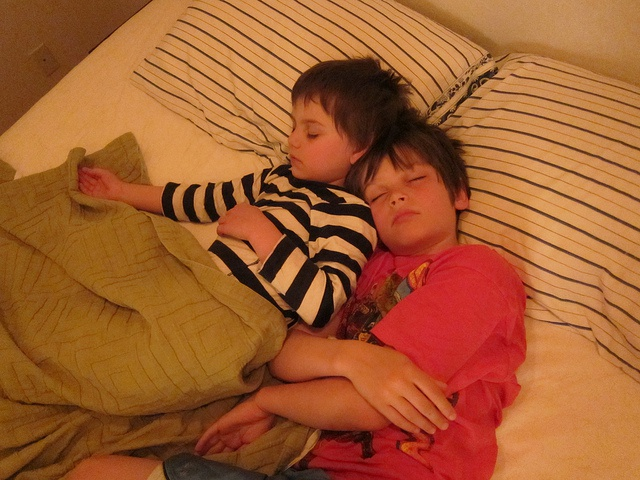Describe the objects in this image and their specific colors. I can see bed in maroon, tan, and red tones, people in maroon and brown tones, and people in maroon, black, brown, and tan tones in this image. 